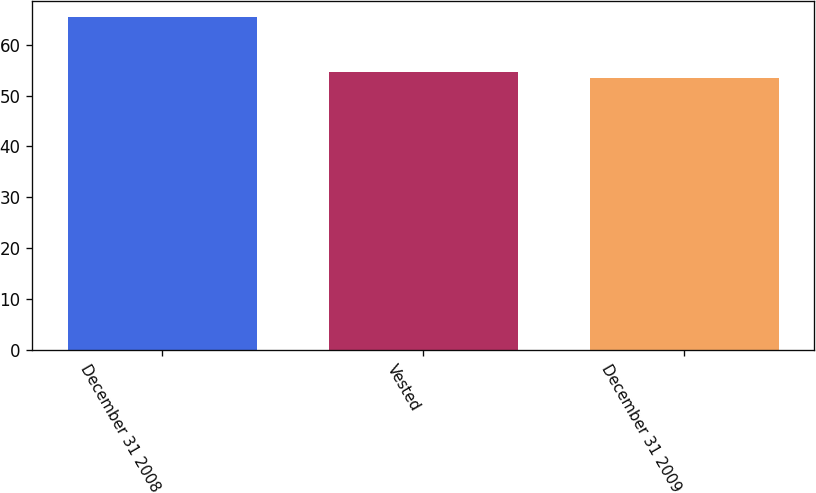Convert chart to OTSL. <chart><loc_0><loc_0><loc_500><loc_500><bar_chart><fcel>December 31 2008<fcel>Vested<fcel>December 31 2009<nl><fcel>65.39<fcel>54.66<fcel>53.45<nl></chart> 